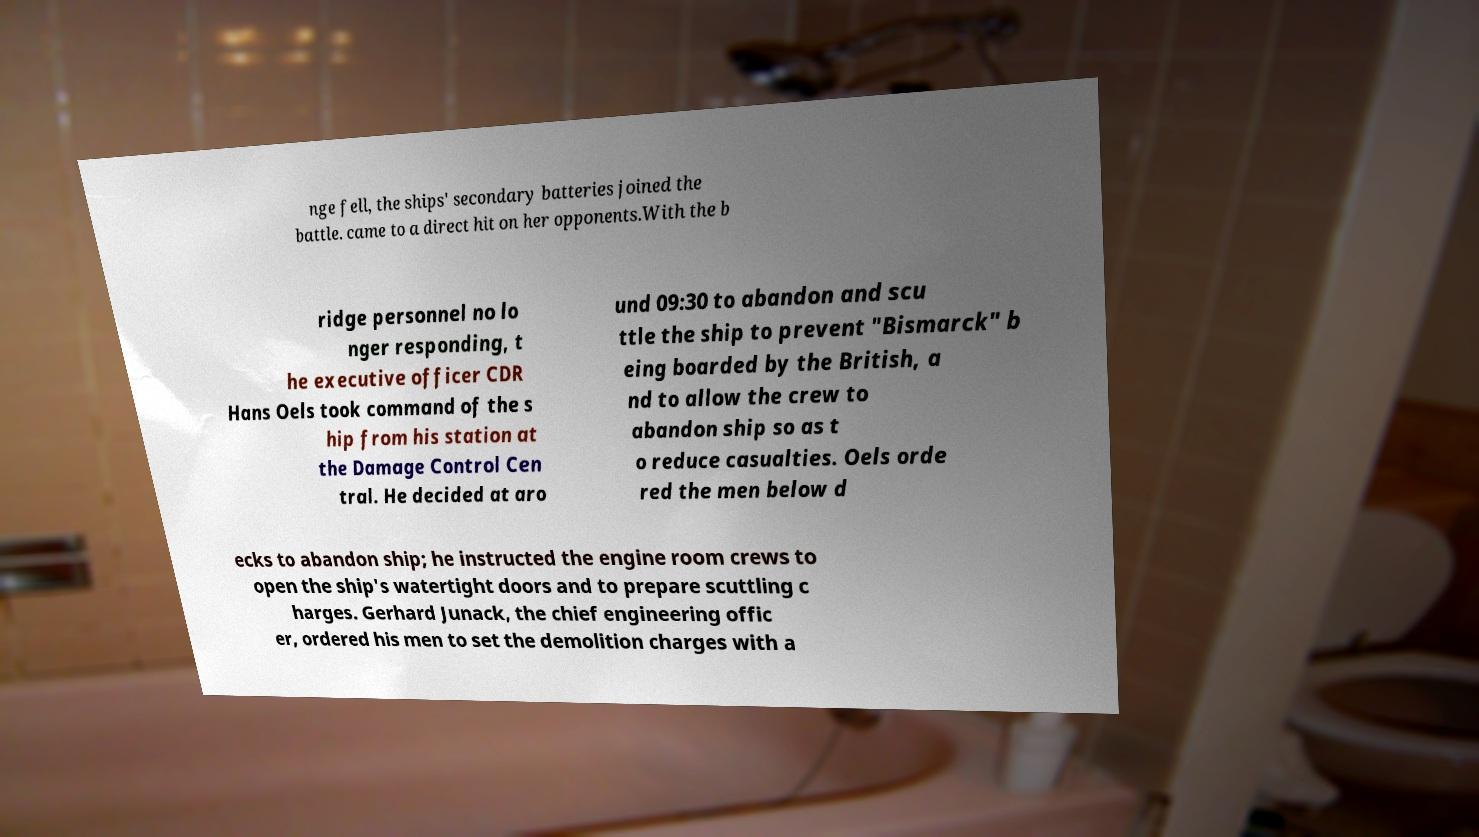For documentation purposes, I need the text within this image transcribed. Could you provide that? nge fell, the ships' secondary batteries joined the battle. came to a direct hit on her opponents.With the b ridge personnel no lo nger responding, t he executive officer CDR Hans Oels took command of the s hip from his station at the Damage Control Cen tral. He decided at aro und 09:30 to abandon and scu ttle the ship to prevent "Bismarck" b eing boarded by the British, a nd to allow the crew to abandon ship so as t o reduce casualties. Oels orde red the men below d ecks to abandon ship; he instructed the engine room crews to open the ship's watertight doors and to prepare scuttling c harges. Gerhard Junack, the chief engineering offic er, ordered his men to set the demolition charges with a 